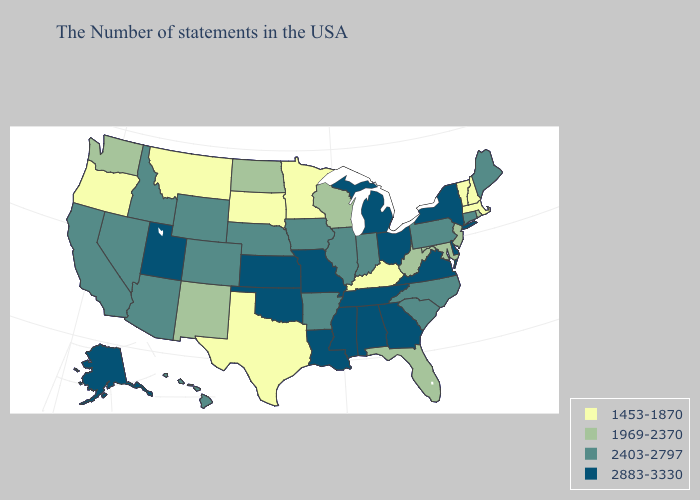What is the value of Indiana?
Concise answer only. 2403-2797. Name the states that have a value in the range 2403-2797?
Give a very brief answer. Maine, Connecticut, Pennsylvania, North Carolina, South Carolina, Indiana, Illinois, Arkansas, Iowa, Nebraska, Wyoming, Colorado, Arizona, Idaho, Nevada, California, Hawaii. Name the states that have a value in the range 2403-2797?
Write a very short answer. Maine, Connecticut, Pennsylvania, North Carolina, South Carolina, Indiana, Illinois, Arkansas, Iowa, Nebraska, Wyoming, Colorado, Arizona, Idaho, Nevada, California, Hawaii. Name the states that have a value in the range 2403-2797?
Give a very brief answer. Maine, Connecticut, Pennsylvania, North Carolina, South Carolina, Indiana, Illinois, Arkansas, Iowa, Nebraska, Wyoming, Colorado, Arizona, Idaho, Nevada, California, Hawaii. Which states have the lowest value in the West?
Quick response, please. Montana, Oregon. How many symbols are there in the legend?
Concise answer only. 4. Among the states that border Colorado , which have the lowest value?
Keep it brief. New Mexico. Among the states that border Montana , does South Dakota have the lowest value?
Be succinct. Yes. Does Missouri have the same value as Kansas?
Short answer required. Yes. Does Ohio have the highest value in the USA?
Quick response, please. Yes. What is the value of Kentucky?
Be succinct. 1453-1870. Does South Dakota have a lower value than Maryland?
Give a very brief answer. Yes. What is the highest value in states that border New Jersey?
Keep it brief. 2883-3330. What is the value of Kentucky?
Keep it brief. 1453-1870. What is the value of Delaware?
Be succinct. 2883-3330. 